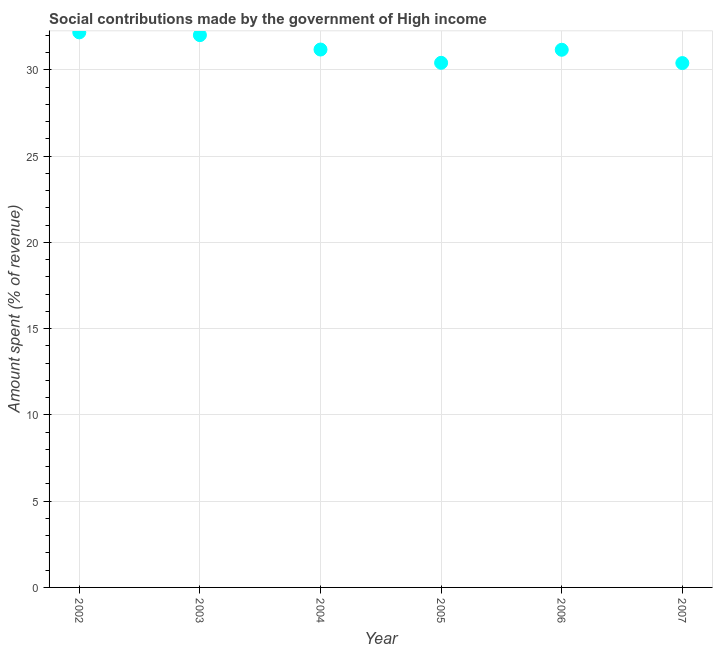What is the amount spent in making social contributions in 2002?
Ensure brevity in your answer.  32.17. Across all years, what is the maximum amount spent in making social contributions?
Provide a succinct answer. 32.17. Across all years, what is the minimum amount spent in making social contributions?
Your answer should be compact. 30.39. What is the sum of the amount spent in making social contributions?
Your answer should be compact. 187.34. What is the difference between the amount spent in making social contributions in 2002 and 2007?
Your answer should be compact. 1.78. What is the average amount spent in making social contributions per year?
Your answer should be very brief. 31.22. What is the median amount spent in making social contributions?
Your response must be concise. 31.17. In how many years, is the amount spent in making social contributions greater than 8 %?
Offer a terse response. 6. What is the ratio of the amount spent in making social contributions in 2002 to that in 2004?
Offer a very short reply. 1.03. What is the difference between the highest and the second highest amount spent in making social contributions?
Give a very brief answer. 0.16. What is the difference between the highest and the lowest amount spent in making social contributions?
Offer a terse response. 1.78. Does the amount spent in making social contributions monotonically increase over the years?
Your response must be concise. No. How many years are there in the graph?
Keep it short and to the point. 6. What is the difference between two consecutive major ticks on the Y-axis?
Offer a terse response. 5. Does the graph contain any zero values?
Your answer should be very brief. No. Does the graph contain grids?
Your response must be concise. Yes. What is the title of the graph?
Provide a short and direct response. Social contributions made by the government of High income. What is the label or title of the Y-axis?
Your response must be concise. Amount spent (% of revenue). What is the Amount spent (% of revenue) in 2002?
Offer a very short reply. 32.17. What is the Amount spent (% of revenue) in 2003?
Keep it short and to the point. 32.01. What is the Amount spent (% of revenue) in 2004?
Give a very brief answer. 31.18. What is the Amount spent (% of revenue) in 2005?
Offer a very short reply. 30.41. What is the Amount spent (% of revenue) in 2006?
Make the answer very short. 31.17. What is the Amount spent (% of revenue) in 2007?
Keep it short and to the point. 30.39. What is the difference between the Amount spent (% of revenue) in 2002 and 2003?
Your answer should be compact. 0.16. What is the difference between the Amount spent (% of revenue) in 2002 and 2004?
Keep it short and to the point. 1. What is the difference between the Amount spent (% of revenue) in 2002 and 2005?
Your answer should be very brief. 1.77. What is the difference between the Amount spent (% of revenue) in 2002 and 2006?
Ensure brevity in your answer.  1.01. What is the difference between the Amount spent (% of revenue) in 2002 and 2007?
Ensure brevity in your answer.  1.78. What is the difference between the Amount spent (% of revenue) in 2003 and 2004?
Keep it short and to the point. 0.84. What is the difference between the Amount spent (% of revenue) in 2003 and 2005?
Keep it short and to the point. 1.61. What is the difference between the Amount spent (% of revenue) in 2003 and 2006?
Provide a short and direct response. 0.85. What is the difference between the Amount spent (% of revenue) in 2003 and 2007?
Your response must be concise. 1.62. What is the difference between the Amount spent (% of revenue) in 2004 and 2005?
Your response must be concise. 0.77. What is the difference between the Amount spent (% of revenue) in 2004 and 2006?
Provide a short and direct response. 0.01. What is the difference between the Amount spent (% of revenue) in 2004 and 2007?
Provide a succinct answer. 0.79. What is the difference between the Amount spent (% of revenue) in 2005 and 2006?
Offer a very short reply. -0.76. What is the difference between the Amount spent (% of revenue) in 2005 and 2007?
Make the answer very short. 0.02. What is the difference between the Amount spent (% of revenue) in 2006 and 2007?
Keep it short and to the point. 0.77. What is the ratio of the Amount spent (% of revenue) in 2002 to that in 2003?
Your response must be concise. 1. What is the ratio of the Amount spent (% of revenue) in 2002 to that in 2004?
Your answer should be very brief. 1.03. What is the ratio of the Amount spent (% of revenue) in 2002 to that in 2005?
Make the answer very short. 1.06. What is the ratio of the Amount spent (% of revenue) in 2002 to that in 2006?
Keep it short and to the point. 1.03. What is the ratio of the Amount spent (% of revenue) in 2002 to that in 2007?
Keep it short and to the point. 1.06. What is the ratio of the Amount spent (% of revenue) in 2003 to that in 2004?
Your response must be concise. 1.03. What is the ratio of the Amount spent (% of revenue) in 2003 to that in 2005?
Offer a terse response. 1.05. What is the ratio of the Amount spent (% of revenue) in 2003 to that in 2006?
Make the answer very short. 1.03. What is the ratio of the Amount spent (% of revenue) in 2003 to that in 2007?
Provide a succinct answer. 1.05. What is the ratio of the Amount spent (% of revenue) in 2004 to that in 2007?
Provide a short and direct response. 1.03. What is the ratio of the Amount spent (% of revenue) in 2006 to that in 2007?
Keep it short and to the point. 1.02. 